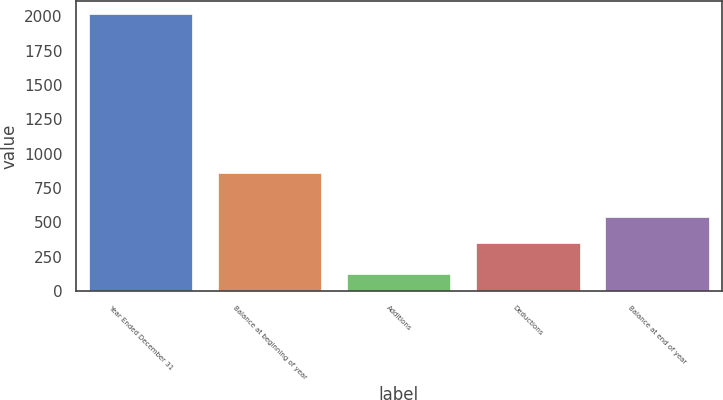<chart> <loc_0><loc_0><loc_500><loc_500><bar_chart><fcel>Year Ended December 31<fcel>Balance at beginning of year<fcel>Additions<fcel>Deductions<fcel>Balance at end of year<nl><fcel>2012<fcel>859<fcel>126<fcel>352<fcel>540.6<nl></chart> 